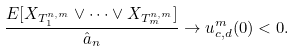<formula> <loc_0><loc_0><loc_500><loc_500>\frac { E [ X _ { T _ { 1 } ^ { n , m } } \vee \cdots \vee X _ { T _ { m } ^ { n , m } } ] } { \hat { a } _ { n } } \to u ^ { m } _ { c , d } ( 0 ) < 0 .</formula> 